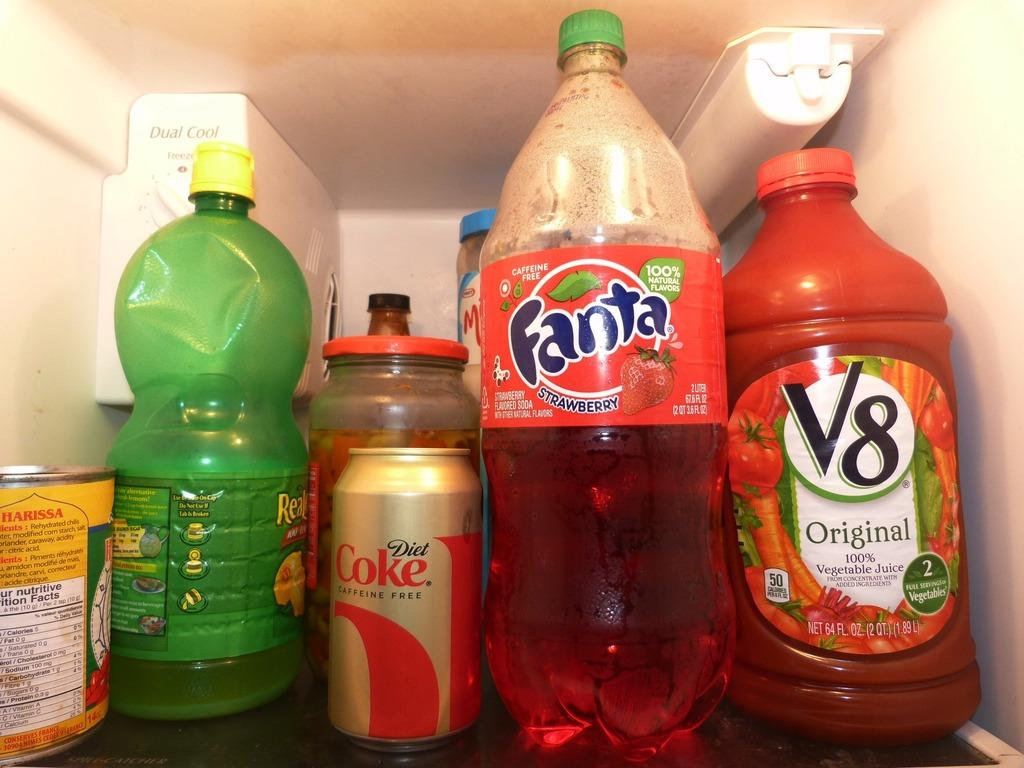Provide a one-sentence caption for the provided image. Bottles of Real Lemon, Fanta, V8, and a can of coke sit on a shelf in the fridge. 